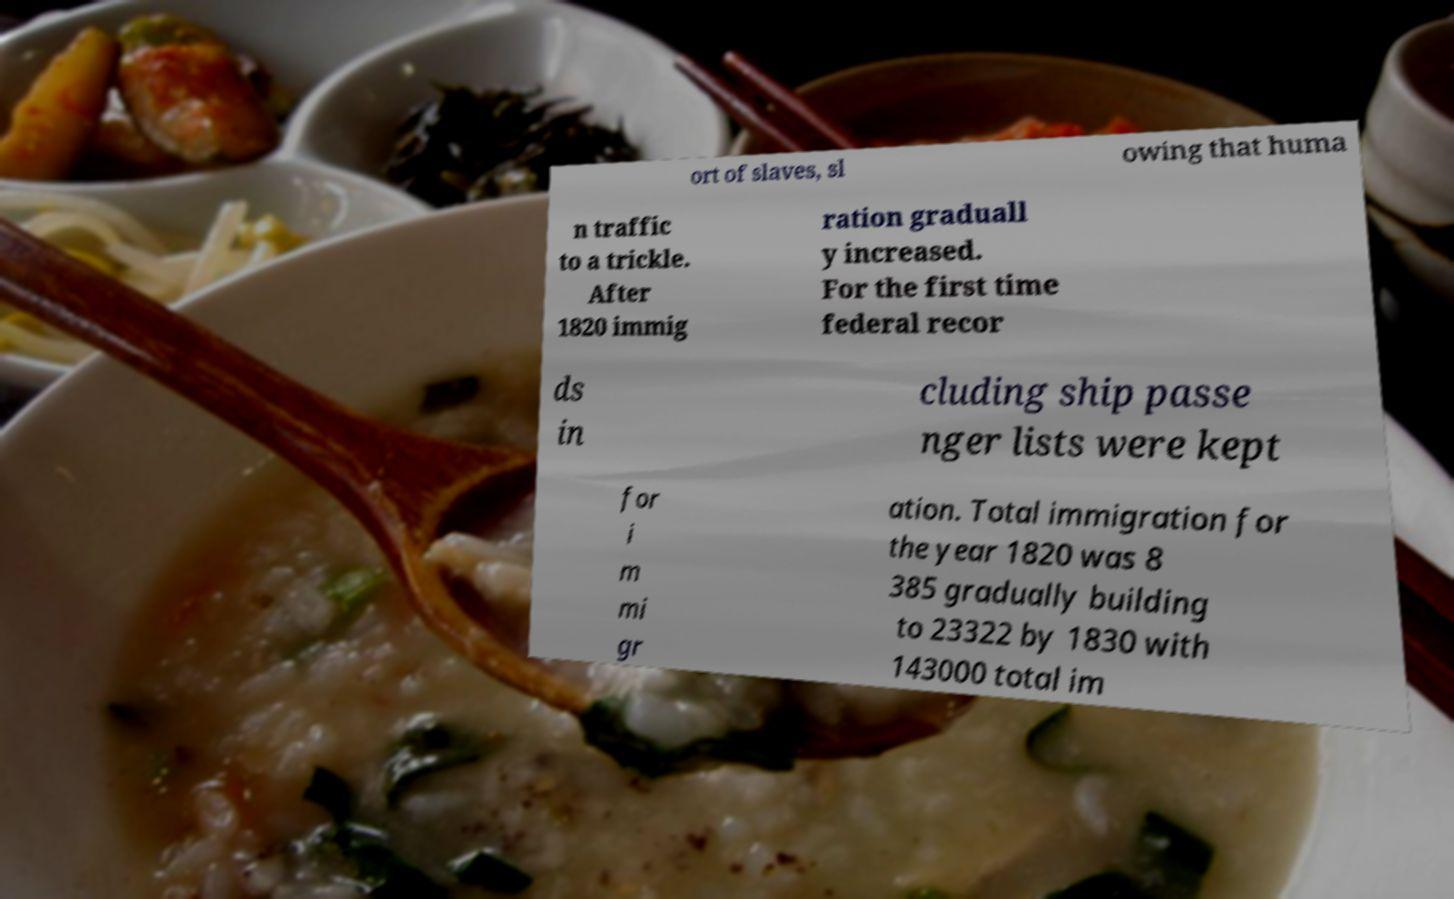What messages or text are displayed in this image? I need them in a readable, typed format. ort of slaves, sl owing that huma n traffic to a trickle. After 1820 immig ration graduall y increased. For the first time federal recor ds in cluding ship passe nger lists were kept for i m mi gr ation. Total immigration for the year 1820 was 8 385 gradually building to 23322 by 1830 with 143000 total im 